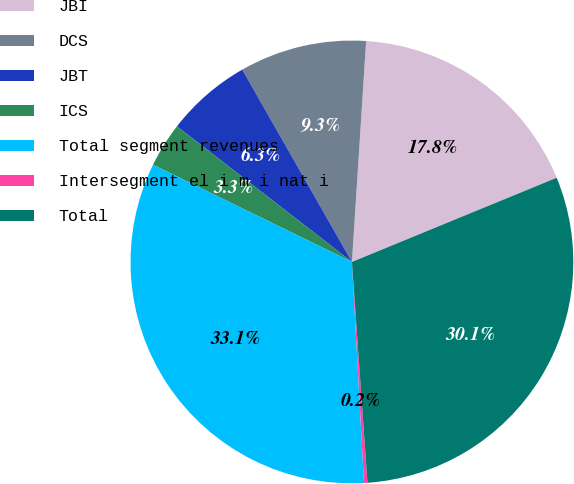Convert chart to OTSL. <chart><loc_0><loc_0><loc_500><loc_500><pie_chart><fcel>JBI<fcel>DCS<fcel>JBT<fcel>ICS<fcel>Total segment revenues<fcel>Intersegment el i m i nat i<fcel>Total<nl><fcel>17.77%<fcel>9.27%<fcel>6.26%<fcel>3.26%<fcel>33.1%<fcel>0.25%<fcel>30.09%<nl></chart> 